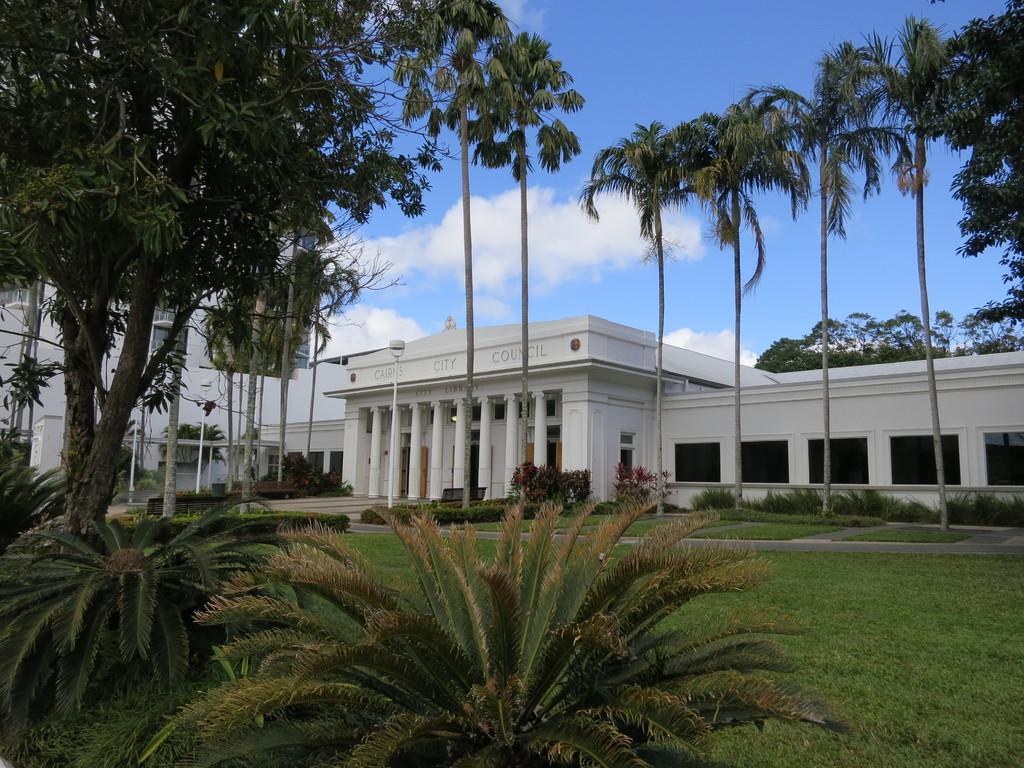Can you describe this image briefly? In this image I can see buildings, grass, plants, trees, bench and cloudy sky. 